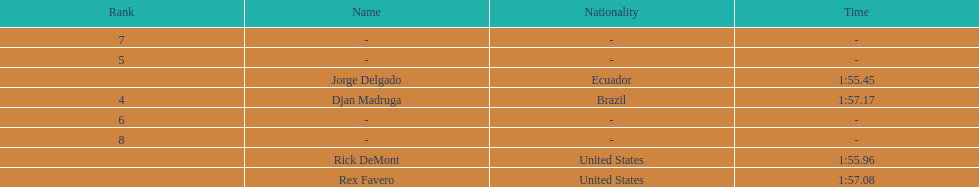Favero finished in 1:57.08. what was the next time? 1:57.17. 